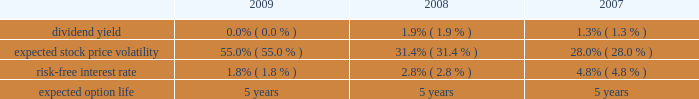Royal caribbean cruises ltd .
Notes to the consolidated financial statements 2014 ( continued ) note 9 .
Stock-based employee compensation we have four stock-based compensation plans , which provide for awards to our officers , directors and key employees .
The plans consist of a 1990 employee stock option plan , a 1995 incentive stock option plan , a 2000 stock award plan , and a 2008 equity plan .
The 1990 stock option plan and the 1995 incentive stock option plan terminated by their terms in march 2000 and february 2005 , respectively .
The 2000 stock award plan , as amended , and the 2008 equity plan provide for the issuance of ( i ) incentive and non-qualified stock options , ( ii ) stock appreciation rights , ( iii ) restricted stock , ( iv ) restricted stock units and ( v ) up to 13000000 performance shares of our common stock for the 2000 stock award plan and up to 5000000 performance shares of our common stock for the 2008 equity plan .
During any calendar year , no one individual shall be granted awards of more than 500000 shares .
Options and restricted stock units outstanding as of december 31 , 2009 vest in equal installments over four to five years from the date of grant .
Generally , options and restricted stock units are forfeited if the recipient ceases to be a director or employee before the shares vest .
Options are granted at a price not less than the fair value of the shares on the date of grant and expire not later than ten years after the date of grant .
We also provide an employee stock purchase plan to facilitate the purchase by employees of up to 800000 shares of common stock in the aggregate .
Offerings to employees are made on a quarterly basis .
Subject to certain limitations , the purchase price for each share of common stock is equal to 90% ( 90 % ) of the average of the market prices of the common stock as reported on the new york stock exchange on the first business day of the purchase period and the last business day of each month of the purchase period .
Shares of common stock of 65005 , 36836 and 20759 were issued under the espp at a weighted-average price of $ 12.78 , $ 20.97 and $ 37.25 during 2009 , 2008 and 2007 , respectively .
Under the chief executive officer 2019s employment agreement we contributed 10086 shares of our common stock quarterly , to a maximum of 806880 shares , to a trust on his behalf .
In january 2009 , the employment agreement and related trust agreement were amended .
Consequently , 768018 shares were distributed from the trust and future quarterly share distributions are issued directly to the chief executive officer .
Total compensation expenses recognized for employee stock-based compensation for the year ended december 31 , 2009 was $ 16.8 million .
Of this amount , $ 16.2 million was included within marketing , selling and administrative expenses and $ 0.6 million was included within payroll and related expenses .
Total compensation expense recognized for employee stock-based compensation for the year ended december 31 , 2008 was $ 5.7 million .
Of this amount , $ 6.4 million , which included a benefit of approximately $ 8.2 million due to a change in the employee forfeiture rate assumption was included within marketing , selling and administrative expenses and income of $ 0.7 million was included within payroll and related expenses which also included a benefit of approximately $ 1.0 million due to the change in the forfeiture rate .
Total compensation expenses recognized for employee stock-based compensation for the year ended december 31 , 2007 was $ 19.0 million .
Of this amount , $ 16.3 million was included within marketing , selling and administrative expenses and $ 2.7 million was included within payroll and related expenses .
The fair value of each stock option grant is estimated on the date of grant using the black-scholes option pricing model .
The estimated fair value of stock options , less estimated forfeitures , is amortized over the vesting period using the graded-vesting method .
The assumptions used in the black-scholes option-pricing model are as follows : expected volatility was based on a combination of historical and implied volatilities .
The risk-free interest rate is based on united states treasury zero coupon issues with a remaining term equal to the expected option life assumed at the date of grant .
The expected term was calculated based on historical experience and represents the time period options actually remain outstanding .
We estimate forfeitures based on historical pre-vesting forfeiture rates and revise those estimates as appropriate to reflect actual experience .
In 2008 , we increased our estimated forfeiture rate from 4% ( 4 % ) for options and 8.5% ( 8.5 % ) for restricted stock units to 20% ( 20 % ) to reflect changes in employee retention rates. .

What was the three year average interest rate for 2007-2009? 
Computations: (((1.8 + 2.8) + 4.8) / 3)
Answer: 3.13333. 